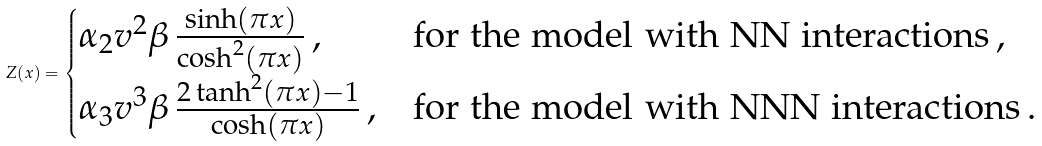Convert formula to latex. <formula><loc_0><loc_0><loc_500><loc_500>Z ( x ) = \begin{cases} \alpha _ { 2 } v ^ { 2 } \beta \, \frac { \sinh ( \pi x ) } { \cosh ^ { 2 } ( \pi x ) } \, , & \text {for the model with NN interactions} \, , \\ \alpha _ { 3 } v ^ { 3 } \beta \, \frac { 2 \tanh ^ { 2 } ( \pi x ) - 1 } { \cosh ( \pi x ) } \, , & \text {for the model with NNN interactions} \, . \end{cases}</formula> 